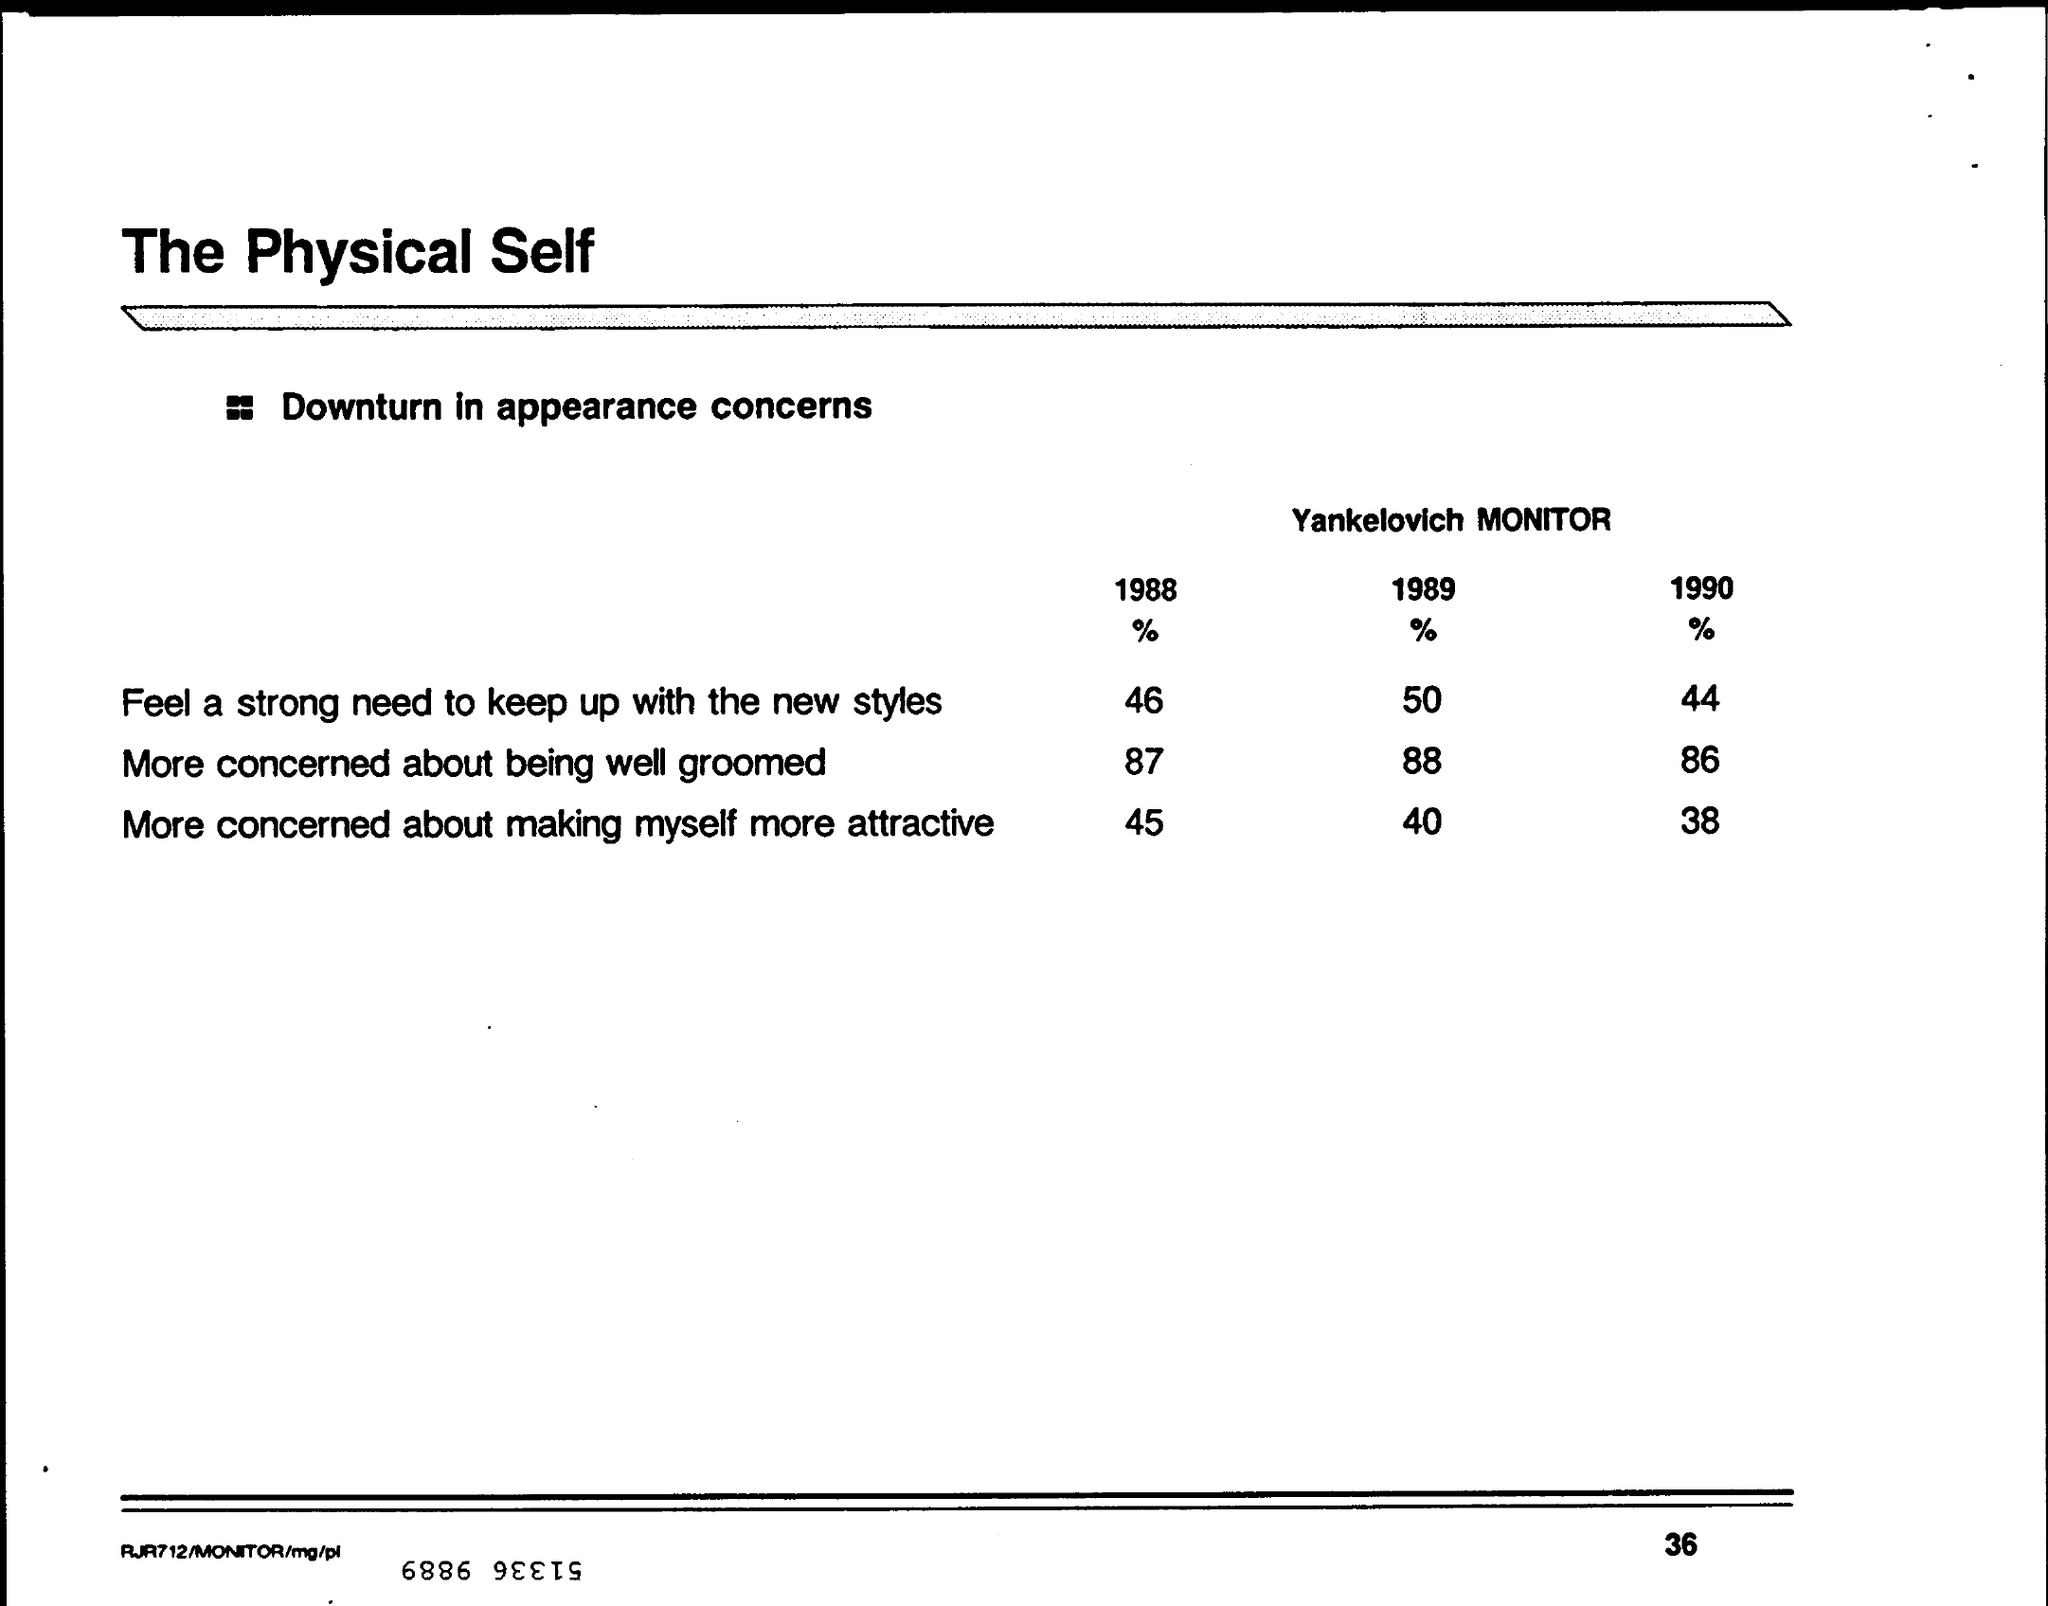List a handful of essential elements in this visual. In 1989, it was reported that approximately 50% of individuals felt a strong need to keep up with new styles and stay current. In the year 1990, I was more concerned about making myself more attractive. Specifically, I was 38% more concerned. The Yankelovich Monitor is the name of a monitor that tracks the decline in appearance concerns. According to a survey conducted in the year 1988, 87% of individuals were more concerned about being well groomed. In the year 1990, it was reported that 86% of individuals were more concerned about their grooming and appearance. 